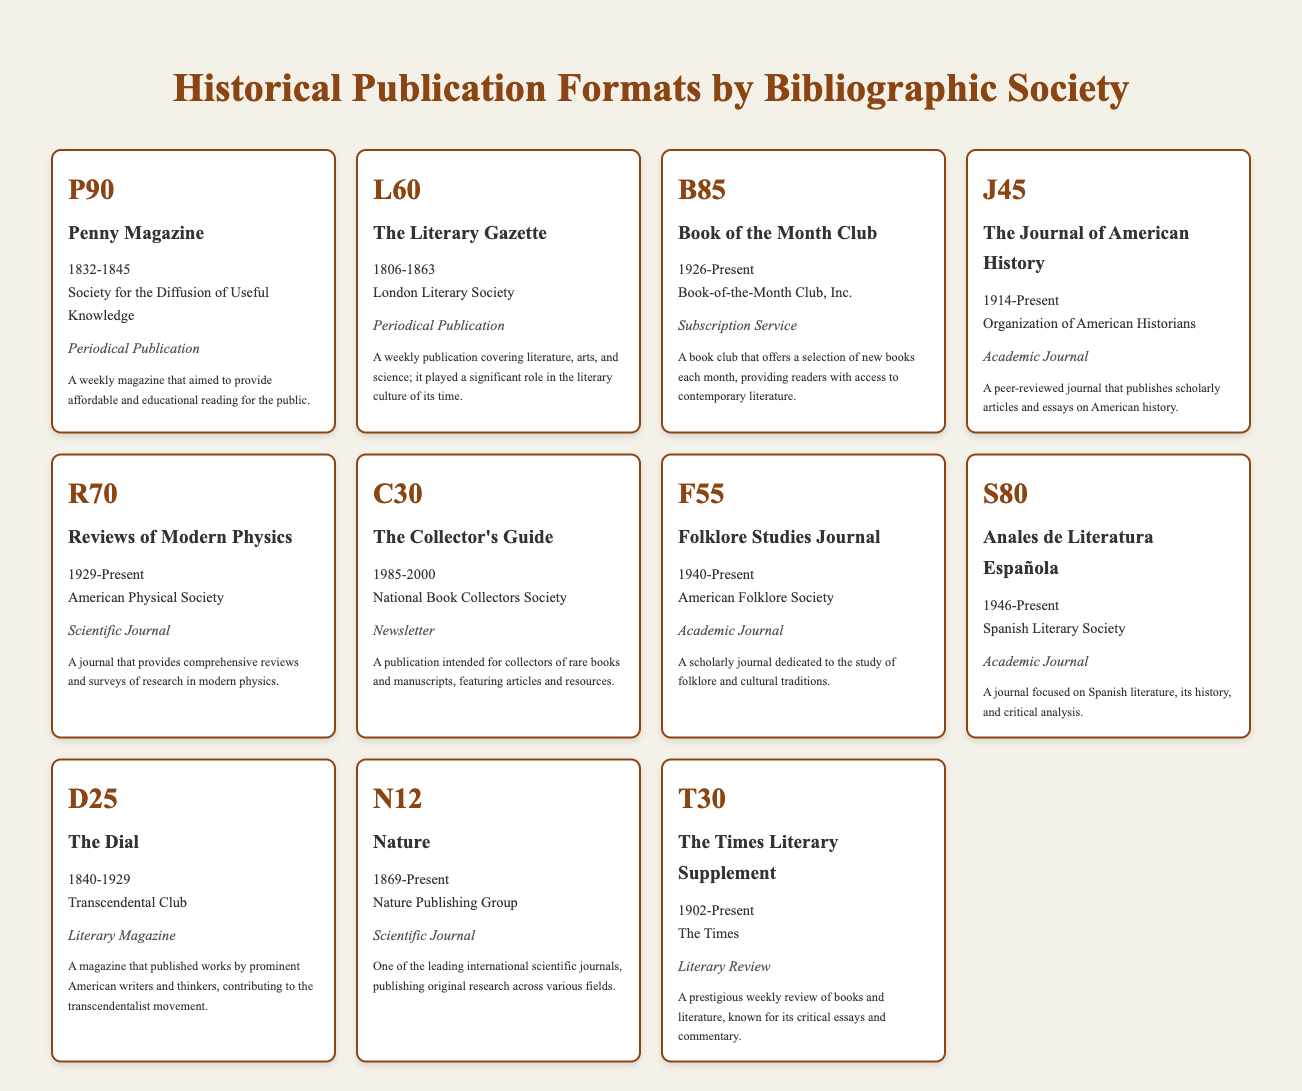What is the publication period for "The Literary Gazette"? The publication period can be found in the table under "historical_period" for "The Literary Gazette". It shows the years 1806-1863.
Answer: 1806-1863 Which bibliographic society is associated with "The Journal of American History"? The bibliographic society for "The Journal of American History" is listed in the table under the relevant entry, it states the "Organization of American Historians".
Answer: Organization of American Historians How many academic journals are listed in the table? To find the number of academic journals, we can scan through the table and count the entries with "Academic Journal" under the format category. There are three entries: "The Journal of American History," "Folklore Studies Journal," and "Anales de Literatura Española." This results in a total of 3 academic journals.
Answer: 3 Which publication has the longest historical period and what are the years? To identify the publication with the longest historical period, we must compare the years listed for each publication. "The Literary Gazette" (1806-1863) has a span of 57 years, "The Dial" (1840-1929) has a span of 89 years, and "The Journal of American History" (1914-Present) is still ongoing. The longest publication is "The Dial" with the years 1840-1929.
Answer: The Dial, 1840-1929 Is "Nature" a newsletter format? The format for "Nature" in the table is noted as "Scientific Journal," not "Newsletter." Therefore, the statement is false.
Answer: No 